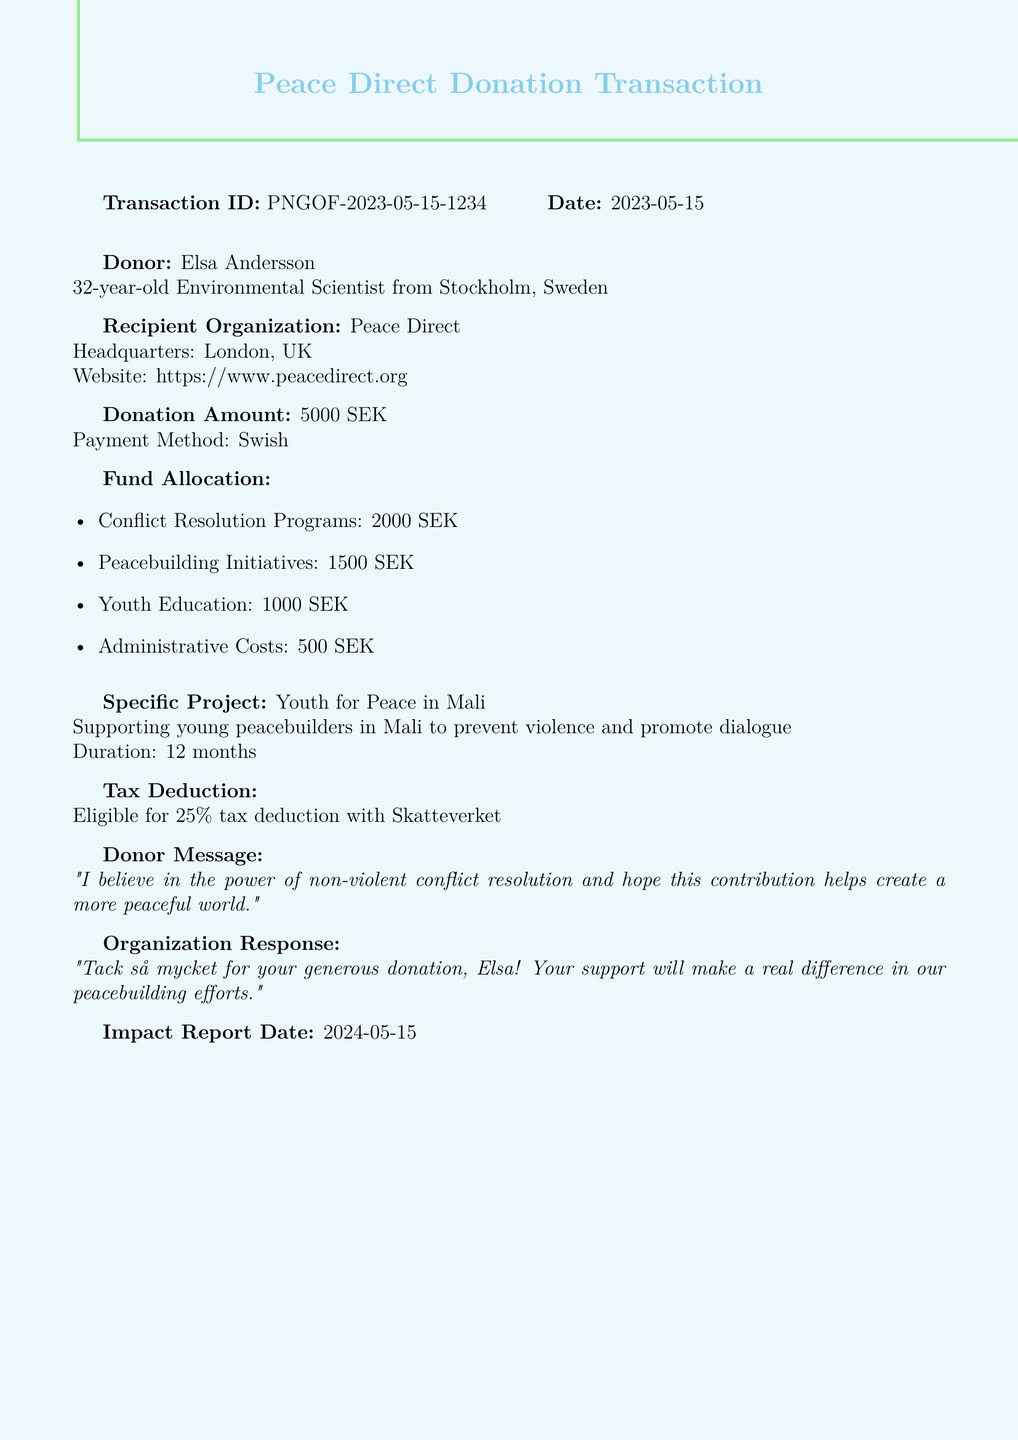What is the transaction ID? The transaction ID is provided in the document to uniquely identify the donation transaction.
Answer: PNGOF-2023-05-15-1234 What is the donation amount? The donation amount is explicitly stated in the document under donation details.
Answer: 5000 SEK What is the name of the recipient organization? The recipient organization is mentioned in the document to identify where the funds are going.
Answer: Peace Direct Which project will the funds support? The specific project supported by the donation is detailed in the document along with its purpose.
Answer: Youth for Peace in Mali How much is allocated to peacebuilding initiatives? The fund allocation section specifies the amounts allocated to different programs, including peacebuilding initiatives.
Answer: 1500 SEK What is the tax deduction percentage? The document states the tax deduction that the donor is eligible for, as well as the corresponding percentage.
Answer: 25 What is the donor's occupation? The document includes information about the donor’s background, including their profession.
Answer: Environmental Scientist What message did the donor include? The donor's message reflects their intention and belief related to the donation and is included in the document.
Answer: "I believe in the power of non-violent conflict resolution and hope this contribution helps create a more peaceful world." When is the impact report date? The document indicates when the organization plans to provide an impact report about the donation's effects.
Answer: 2024-05-15 